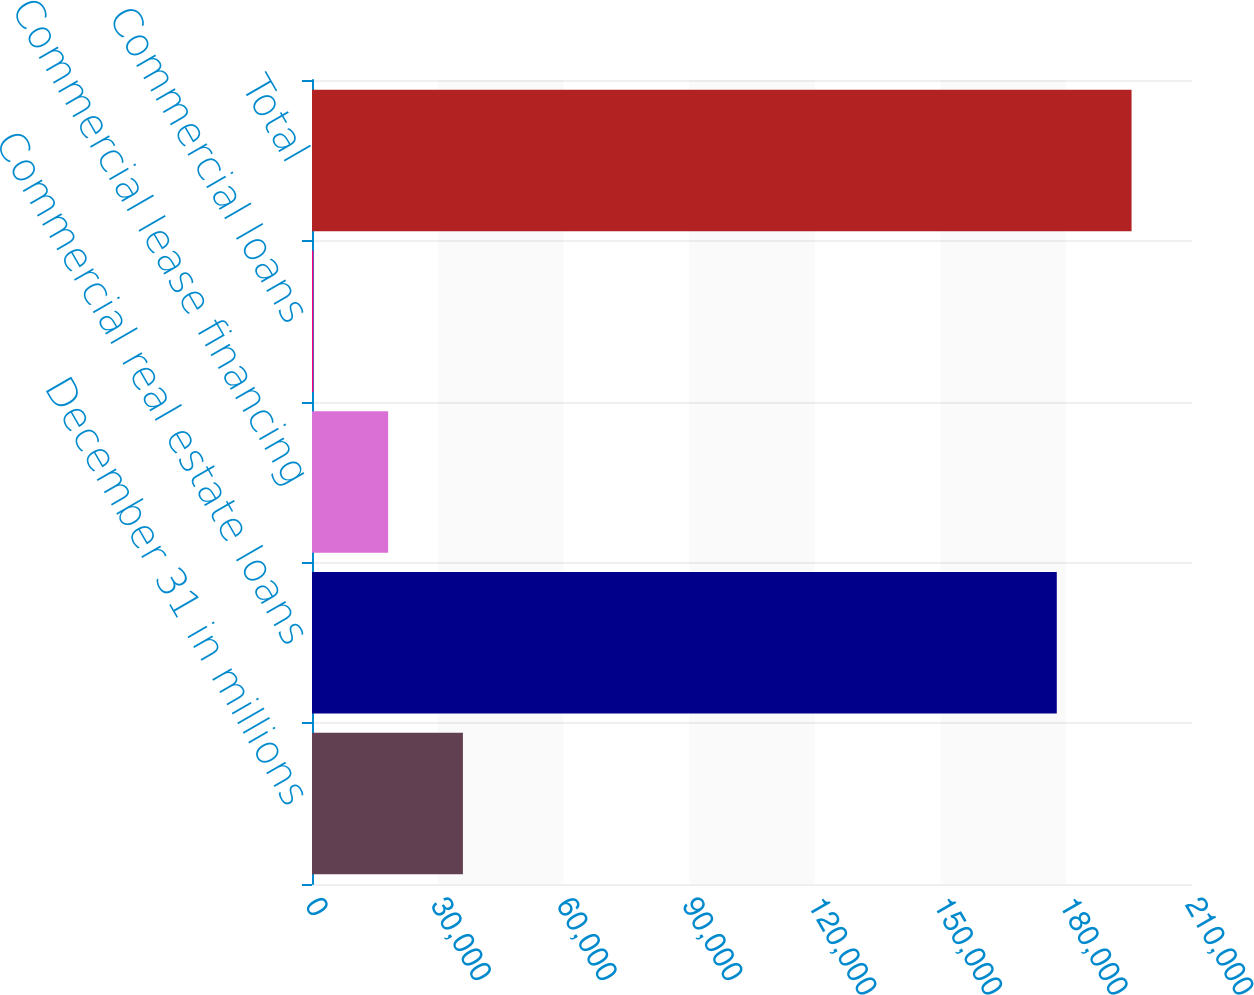Convert chart to OTSL. <chart><loc_0><loc_0><loc_500><loc_500><bar_chart><fcel>December 31 in millions<fcel>Commercial real estate loans<fcel>Commercial lease financing<fcel>Commercial loans<fcel>Total<nl><fcel>36016.6<fcel>177731<fcel>18171.8<fcel>327<fcel>195576<nl></chart> 